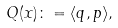Convert formula to latex. <formula><loc_0><loc_0><loc_500><loc_500>Q ( x ) \colon = \langle q , p \rangle ,</formula> 